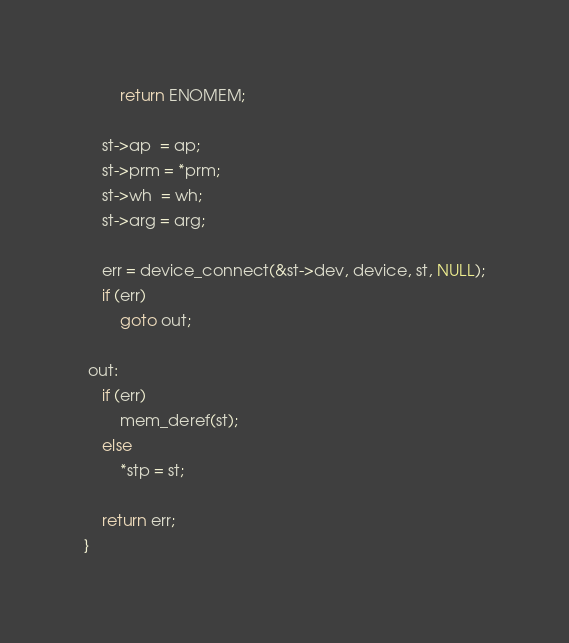Convert code to text. <code><loc_0><loc_0><loc_500><loc_500><_C_>		return ENOMEM;

	st->ap  = ap;
	st->prm = *prm;
	st->wh  = wh;
	st->arg = arg;

	err = device_connect(&st->dev, device, st, NULL);
	if (err)
		goto out;

 out:
	if (err)
		mem_deref(st);
	else
		*stp = st;

	return err;
}
</code> 